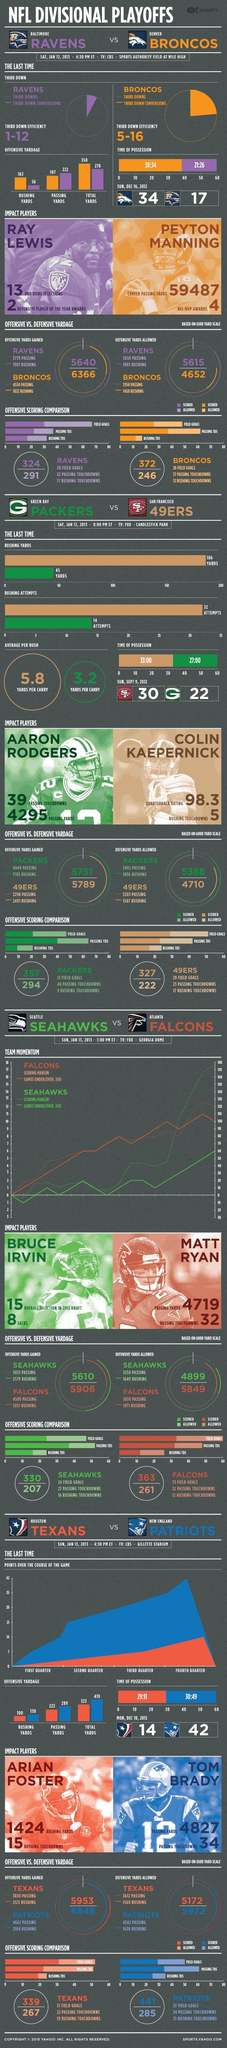Outline some significant characteristics in this image. The Broncos have scored 187 passing yards. 